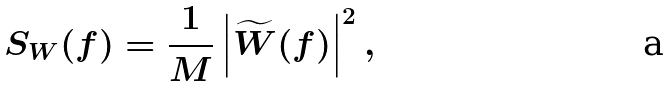<formula> <loc_0><loc_0><loc_500><loc_500>S _ { W } ( f ) = \frac { 1 } { M } \left | \widetilde { W } ( f ) \right | ^ { 2 } ,</formula> 